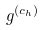<formula> <loc_0><loc_0><loc_500><loc_500>g ^ { ( c _ { h } ) }</formula> 